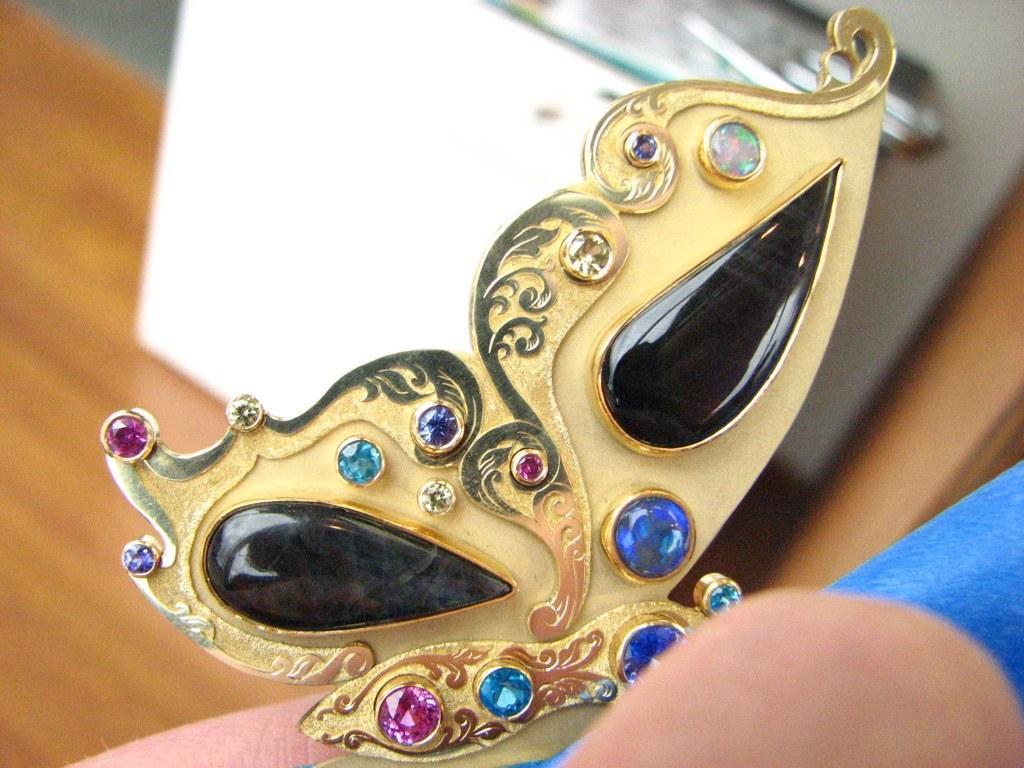How would you summarize this image in a sentence or two? In this image I can see a golden colour face mask. On the right side of this image I can see a blue colour thing and I can see this image is little bit blurry in the background. 